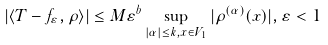<formula> <loc_0><loc_0><loc_500><loc_500>| \langle T - f _ { \varepsilon } , \rho \rangle | \leq M \varepsilon ^ { b } \sup _ { | \alpha | \leq k , x \in V _ { 1 } } | \rho ^ { ( \alpha ) } ( x ) | , \varepsilon < 1</formula> 